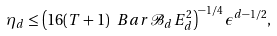<formula> <loc_0><loc_0><loc_500><loc_500>\eta _ { d } \leq \left ( 1 6 ( T + 1 ) \ B a r { \mathcal { B } } _ { d } E _ { d } ^ { 2 } \right ) ^ { - 1 / 4 } \epsilon ^ { d - 1 / 2 } ,</formula> 